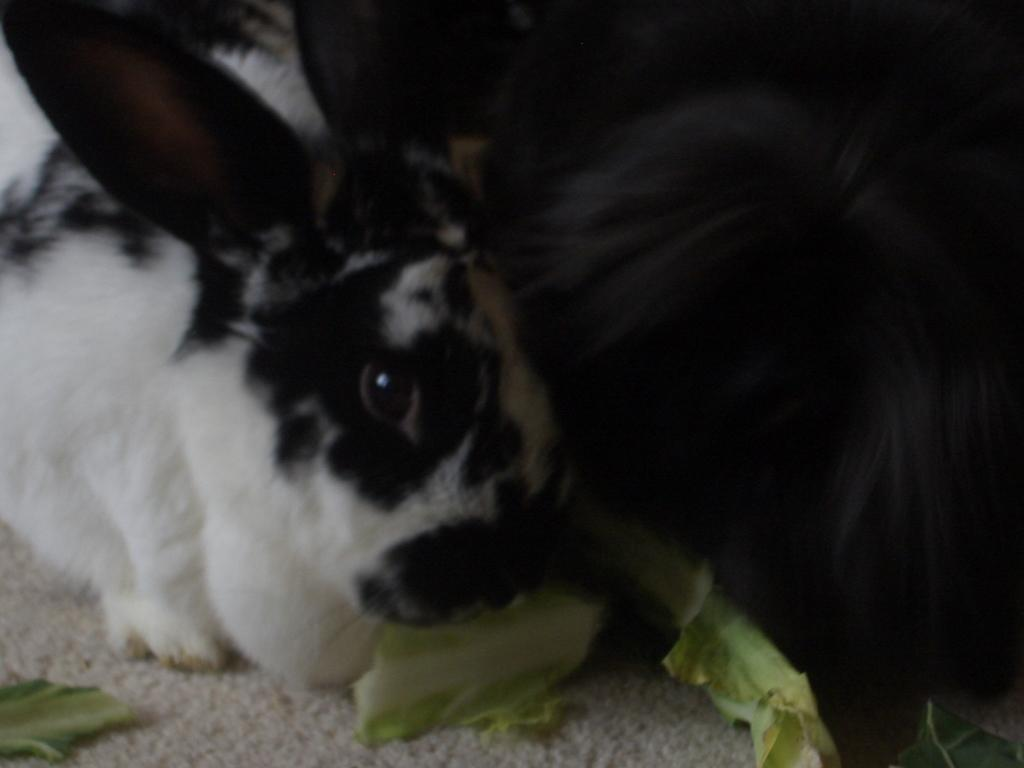What types of living organisms can be seen on the surface in the image? There are animals on the surface in the image. What type of vegetation can be seen in the image? There are leaves visible in the image. Where is the river located in the image? There is no river present in the image. How many hydrants can be seen on the hill in the image? There is no hill or hydrant present in the image. 